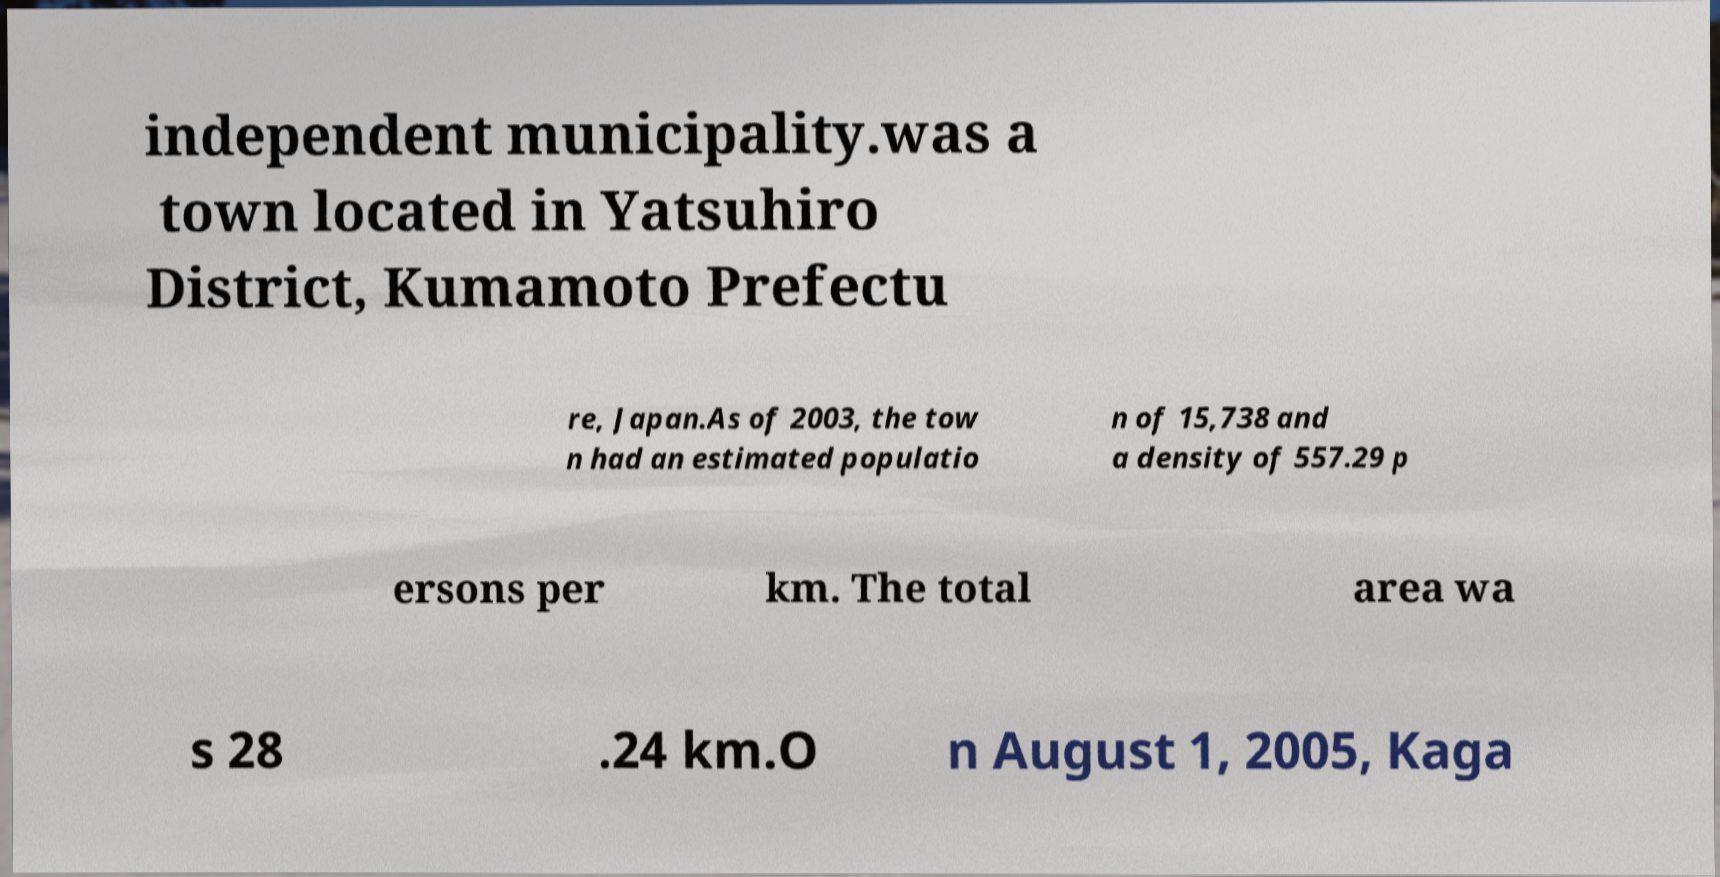Please identify and transcribe the text found in this image. independent municipality.was a town located in Yatsuhiro District, Kumamoto Prefectu re, Japan.As of 2003, the tow n had an estimated populatio n of 15,738 and a density of 557.29 p ersons per km. The total area wa s 28 .24 km.O n August 1, 2005, Kaga 